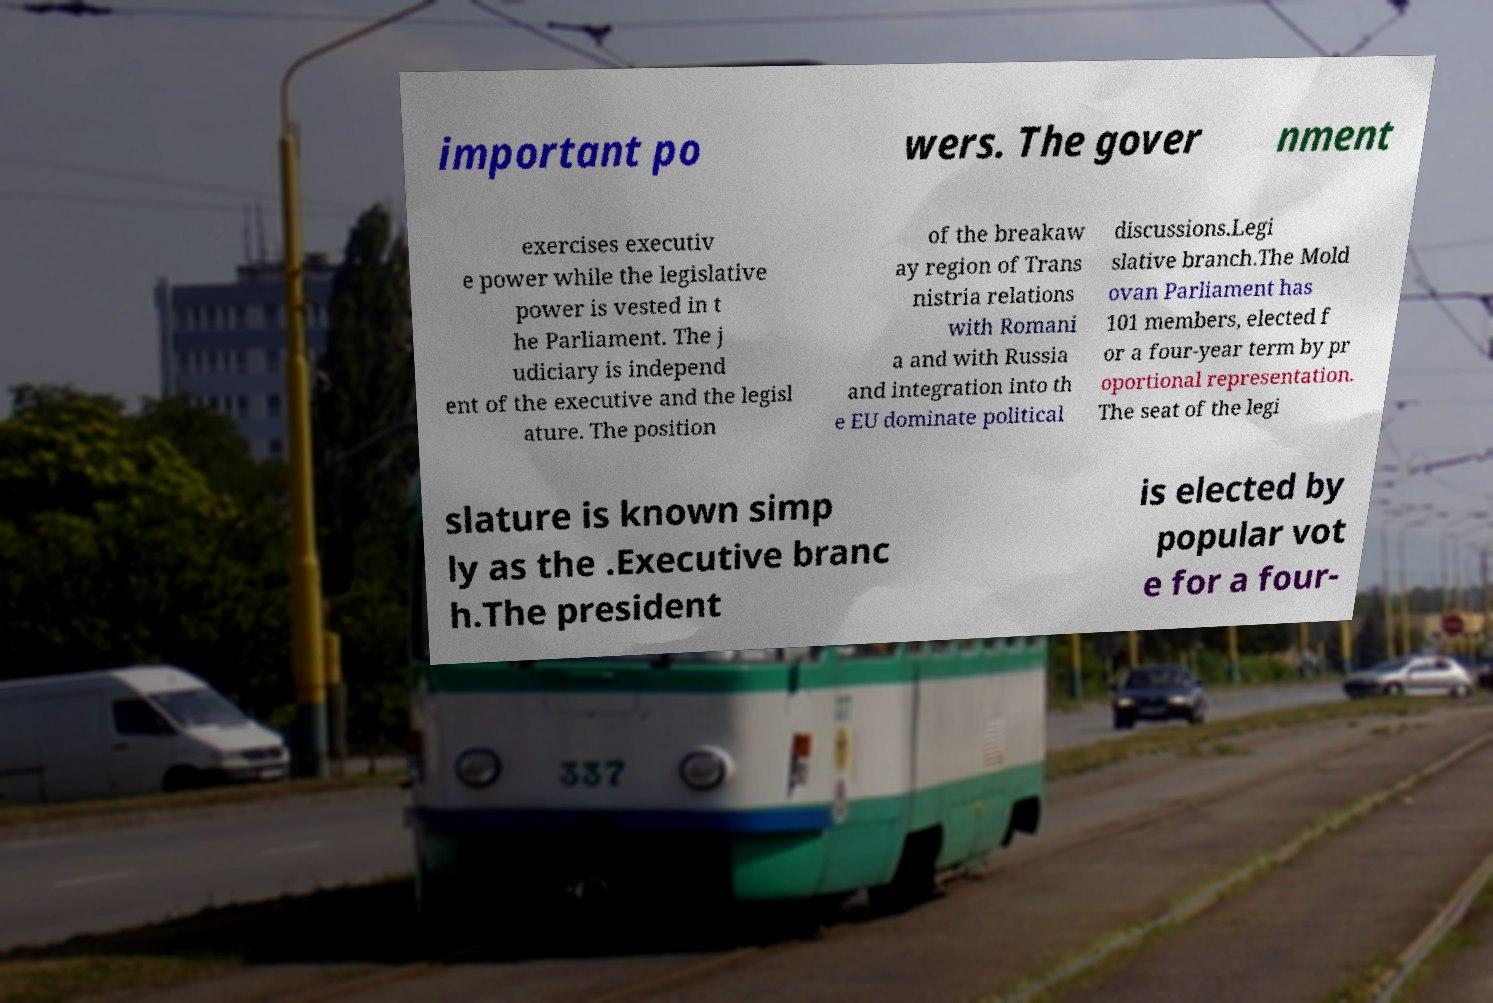Can you accurately transcribe the text from the provided image for me? important po wers. The gover nment exercises executiv e power while the legislative power is vested in t he Parliament. The j udiciary is independ ent of the executive and the legisl ature. The position of the breakaw ay region of Trans nistria relations with Romani a and with Russia and integration into th e EU dominate political discussions.Legi slative branch.The Mold ovan Parliament has 101 members, elected f or a four-year term by pr oportional representation. The seat of the legi slature is known simp ly as the .Executive branc h.The president is elected by popular vot e for a four- 